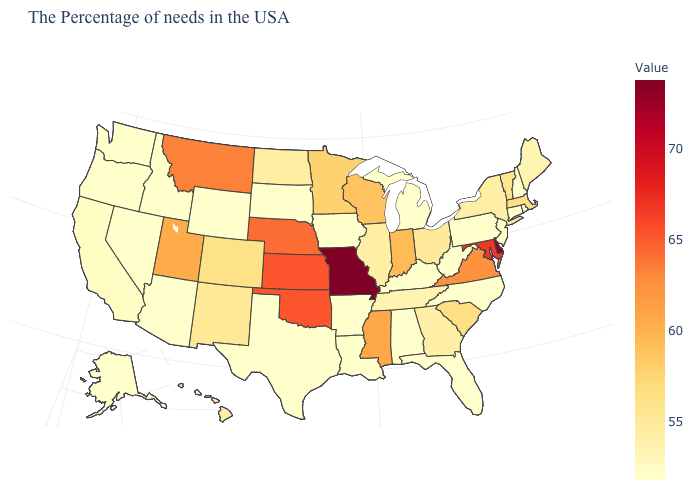Which states have the highest value in the USA?
Short answer required. Missouri. Is the legend a continuous bar?
Short answer required. Yes. 